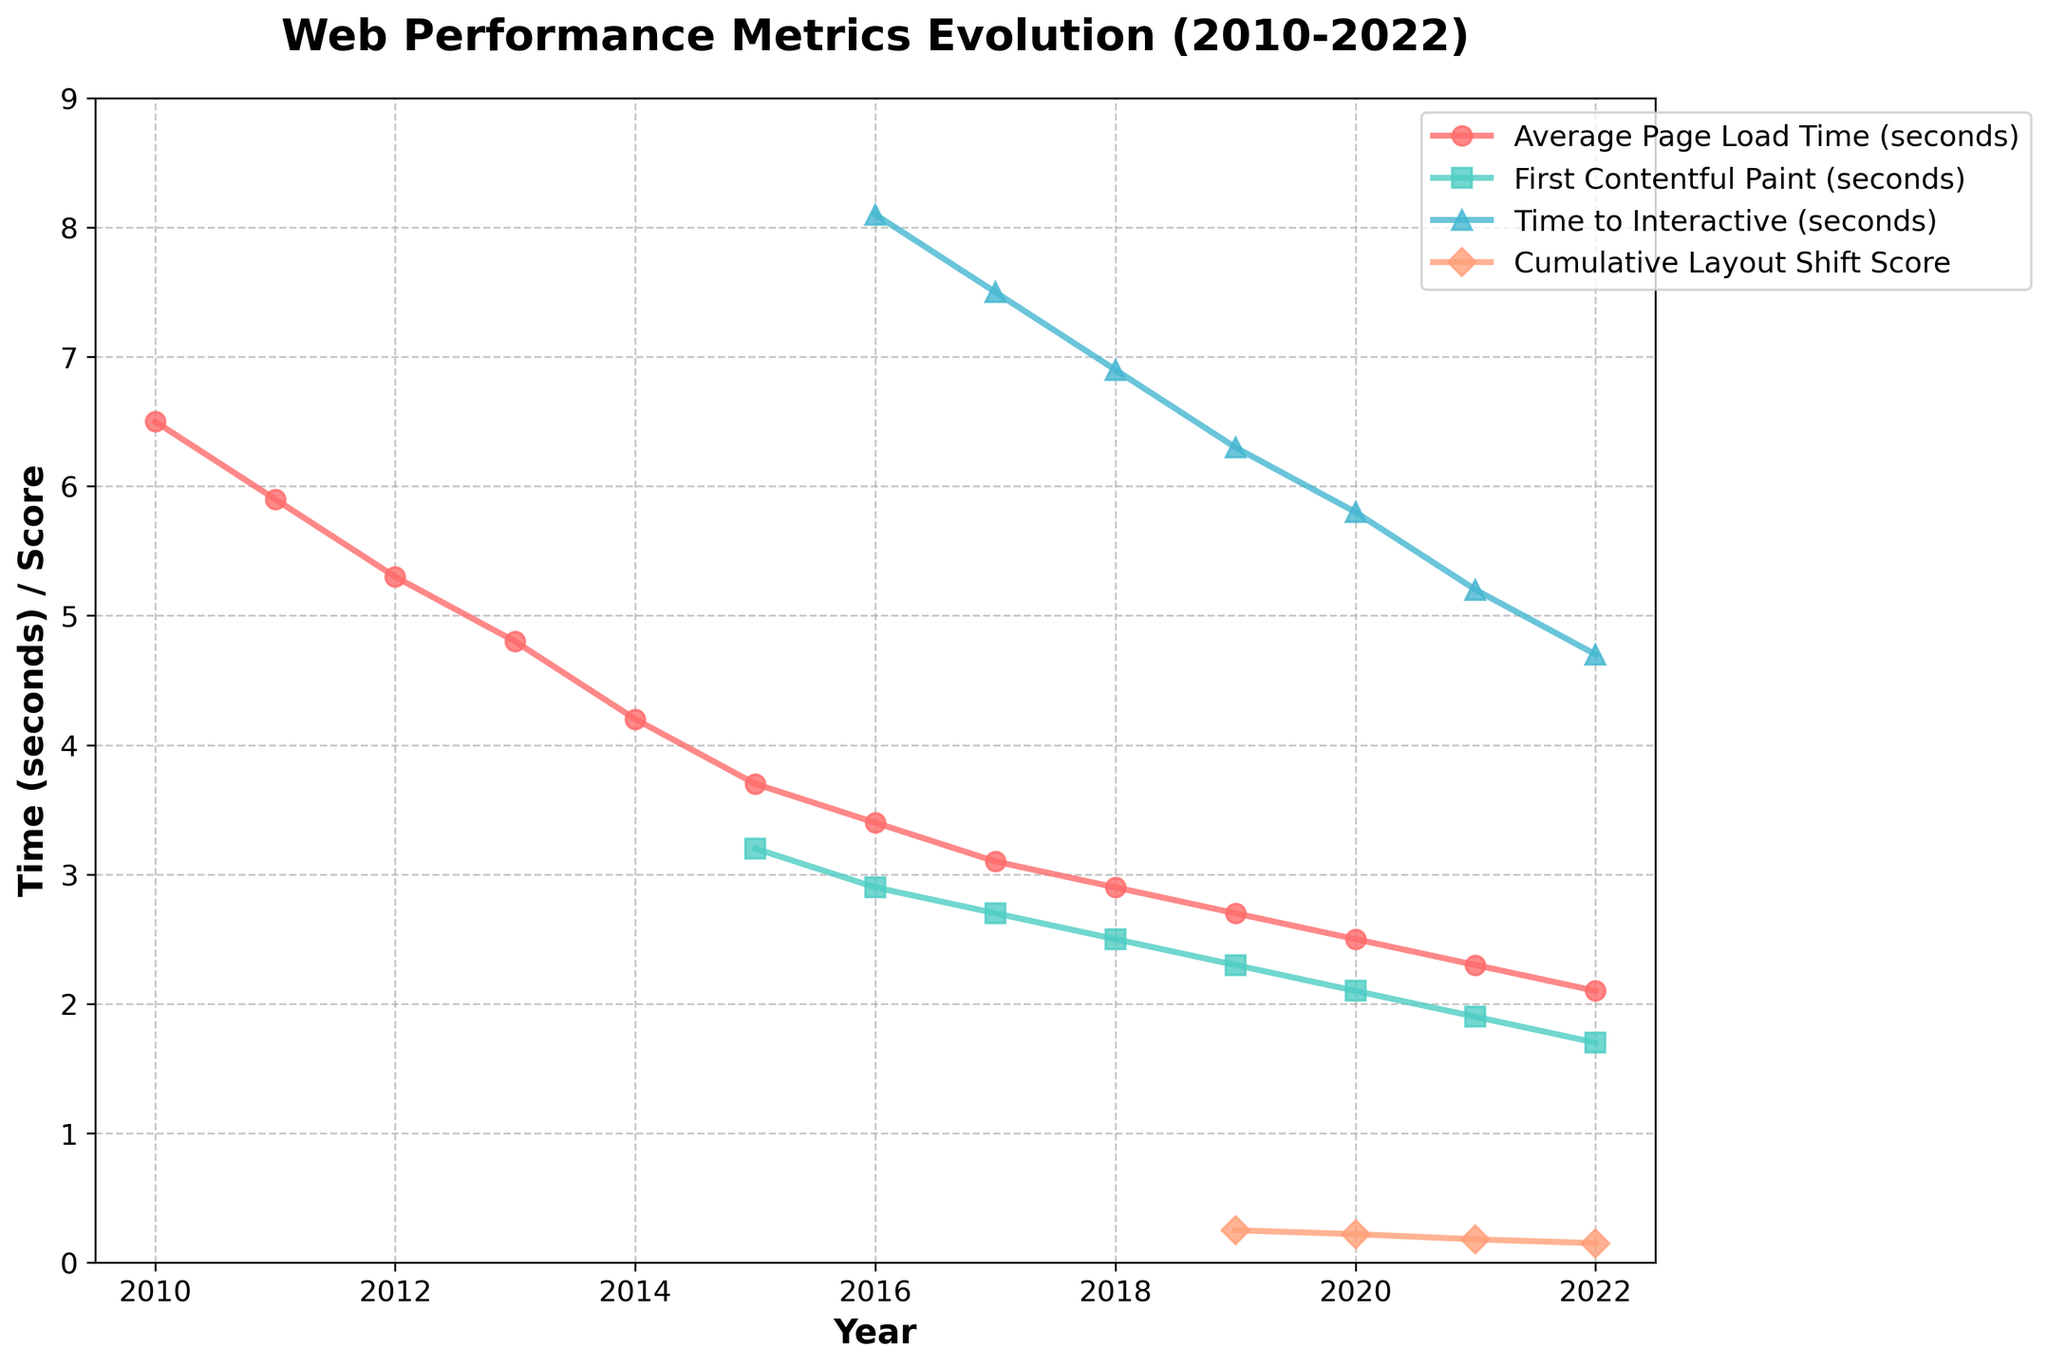Which year had the highest Average Page Load Time (seconds)? Look at the line for 'Average Page Load Time (seconds)', which is marked with circles, and find the highest point. The highest point is at the beginning of the data series, which corresponds to 2010.
Answer: 2010 How has the First Contentful Paint (seconds) changed from 2015 to 2022? Observe the line for 'First Contentful Paint (seconds)', which is marked with squares. Note the values for the years 2015 and 2022, and calculate the change. In 2015, it was 3.2 seconds, and in 2022, it was 1.7 seconds. The change is 3.2 - 1.7 = 1.5 seconds.
Answer: Decreased by 1.5 seconds Which metric showed a consistent decrease over the years from 2010 to 2022? Examine all the lines and check which one consistently decreases over the years. The line for 'Average Page Load Time (seconds)' shows a consistent downward trend from 2010 to 2022.
Answer: Average Page Load Time (seconds) In which year does the Cumulative Layout Shift Score first appear in the data set? Identify the line for 'Cumulative Layout Shift Score', marked with triangles, and find the year where it first has a data point. This line first appears in 2019.
Answer: 2019 Compare the Time to Interactive (seconds) in 2016 and 2021. Which year had a lower value? Look at the line for 'Time to Interactive (seconds)', marked with upward triangles, and compare the values for 2016 and 2021. In 2016, it was 8.1 seconds, and in 2021, it was 5.2 seconds. 2021 had a lower value.
Answer: 2021 What was the Time to Interactive (seconds) in 2016, and how did it change by 2022? Identify the 'Time to Interactive (seconds)' line and read the values for 2016 and 2022. In 2016, the value was 8.1 seconds, and in 2022, it was 4.7 seconds. The change is calculated as 8.1 - 4.7 = 3.4 seconds.
Answer: Decreased by 3.4 seconds Determine the average First Contentful Paint (seconds) from 2015 to 2022. Summarize the 'First Contentful Paint (seconds)' values from 2015 to 2022 and calculate the average. The values are 3.2, 2.9, 2.7, 2.5, 2.3, 2.1, 1.9, and 1.7. The total is 19.3 and there are 8 values, so the average is 19.3 / 8 = 2.41 seconds.
Answer: 2.41 seconds Which metric has improved the most from 2010 to 2022? Provide the amount of change. Look at the data for all metrics over this timeframe. 'Average Page Load Time (seconds)' decreased from 6.5 seconds in 2010 to 2.1 seconds in 2022. The change is 6.5 - 2.1 = 4.4 seconds, the most significant change among the metrics.
Answer: Average Page Load Time (seconds) by 4.4 seconds How do the Average Page Load Time (seconds) in 2010 and the First Contentful Paint (seconds) in 2022 compare? Compare the value for 'Average Page Load Time (seconds)' in 2010, which is 6.5 seconds, with the 'First Contentful Paint (seconds)' in 2022, which is 1.7 seconds. The Average Page Load Time in 2010 is higher.
Answer: Average Page Load Time (seconds) in 2010 is higher What is the trend of the Cumulative Layout Shift Score from 2019 to 2022? Examine the 'Cumulative Layout Shift Score' line between 2019 and 2022. Starting at 0.25 in 2019, it decreased to 0.22 in 2020, 0.18 in 2021, and 0.15 in 2022, showing a downward trend.
Answer: Downward trend 